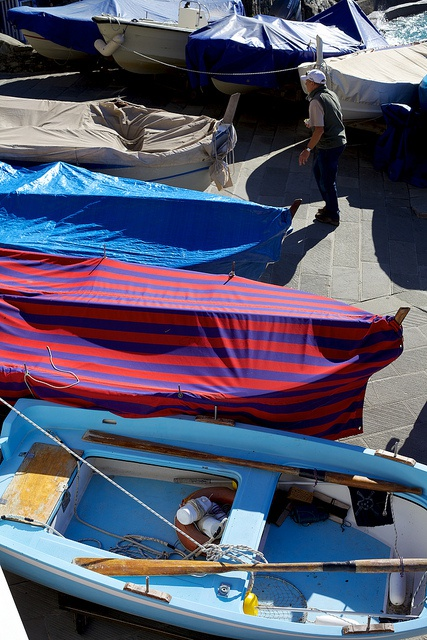Describe the objects in this image and their specific colors. I can see boat in navy, blue, black, and gray tones, boat in navy, maroon, salmon, and blue tones, boat in navy, lightblue, and blue tones, boat in navy, gray, darkgray, black, and lightgray tones, and boat in navy, black, white, and darkgray tones in this image. 